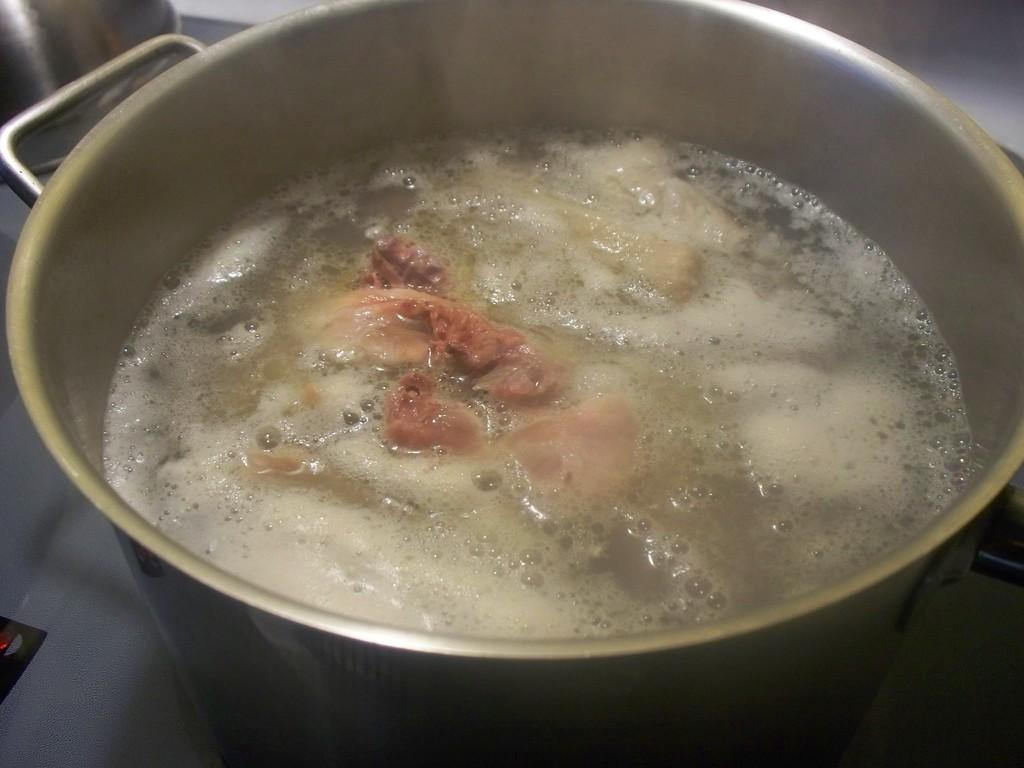What is on the stove in the image? There is a vessel on the stove in the image. What is inside the vessel? It appears that there is meat in the water in the vessel. What type of underwear is hanging on the stove in the image? There is no underwear present in the image. How many friends are visible in the image? There are no friends visible in the image. 